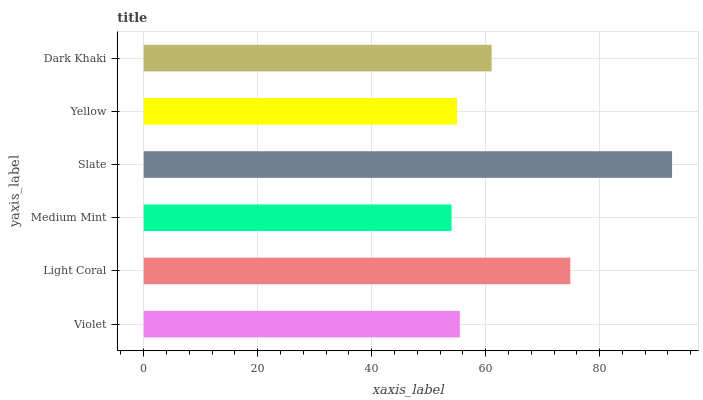Is Medium Mint the minimum?
Answer yes or no. Yes. Is Slate the maximum?
Answer yes or no. Yes. Is Light Coral the minimum?
Answer yes or no. No. Is Light Coral the maximum?
Answer yes or no. No. Is Light Coral greater than Violet?
Answer yes or no. Yes. Is Violet less than Light Coral?
Answer yes or no. Yes. Is Violet greater than Light Coral?
Answer yes or no. No. Is Light Coral less than Violet?
Answer yes or no. No. Is Dark Khaki the high median?
Answer yes or no. Yes. Is Violet the low median?
Answer yes or no. Yes. Is Violet the high median?
Answer yes or no. No. Is Slate the low median?
Answer yes or no. No. 